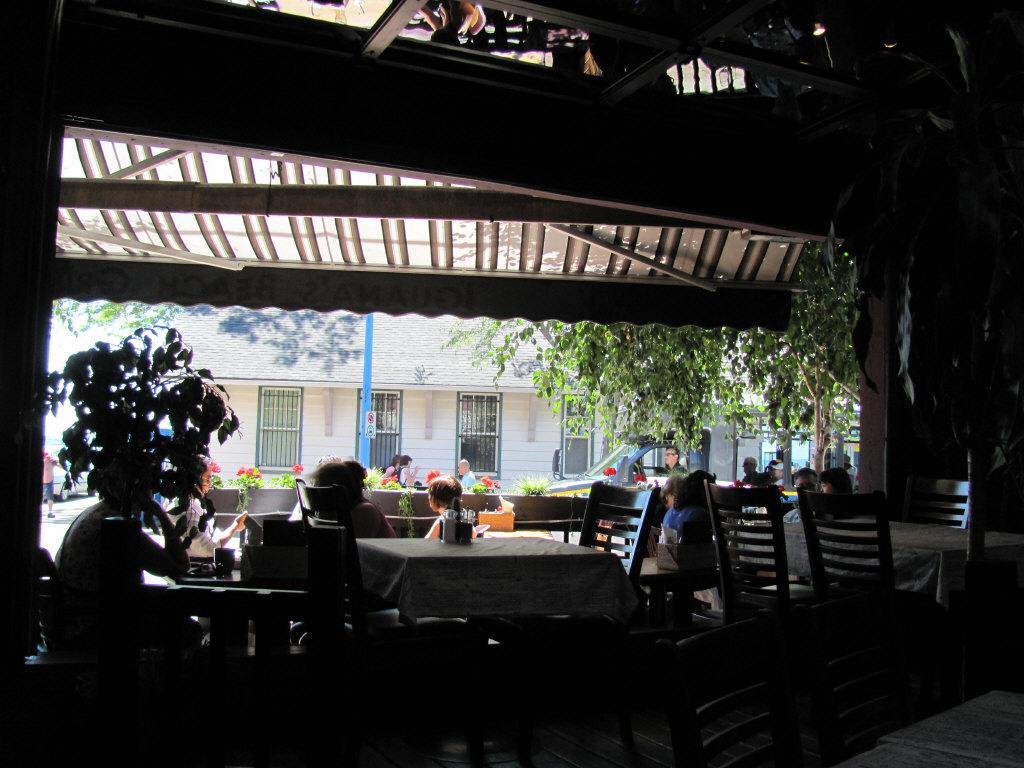Please provide a concise description of this image. This picture is taken inside the restaurant. In this image there are so many tables around which there are chairs. There are few people sitting in the chairs. In the background there is a house with the windows. At the top there is a cloth which is used as a roof. On the left side there is a plant. On the right side there is a car in the background. Beside the car there are trees. There are flower plants and a pole in the middle beside the road. 